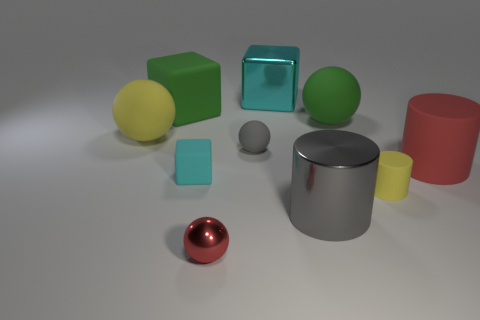Subtract all cubes. How many objects are left? 7 Add 4 small rubber cylinders. How many small rubber cylinders exist? 5 Subtract 1 yellow spheres. How many objects are left? 9 Subtract all small cyan objects. Subtract all big gray blocks. How many objects are left? 9 Add 6 big green objects. How many big green objects are left? 8 